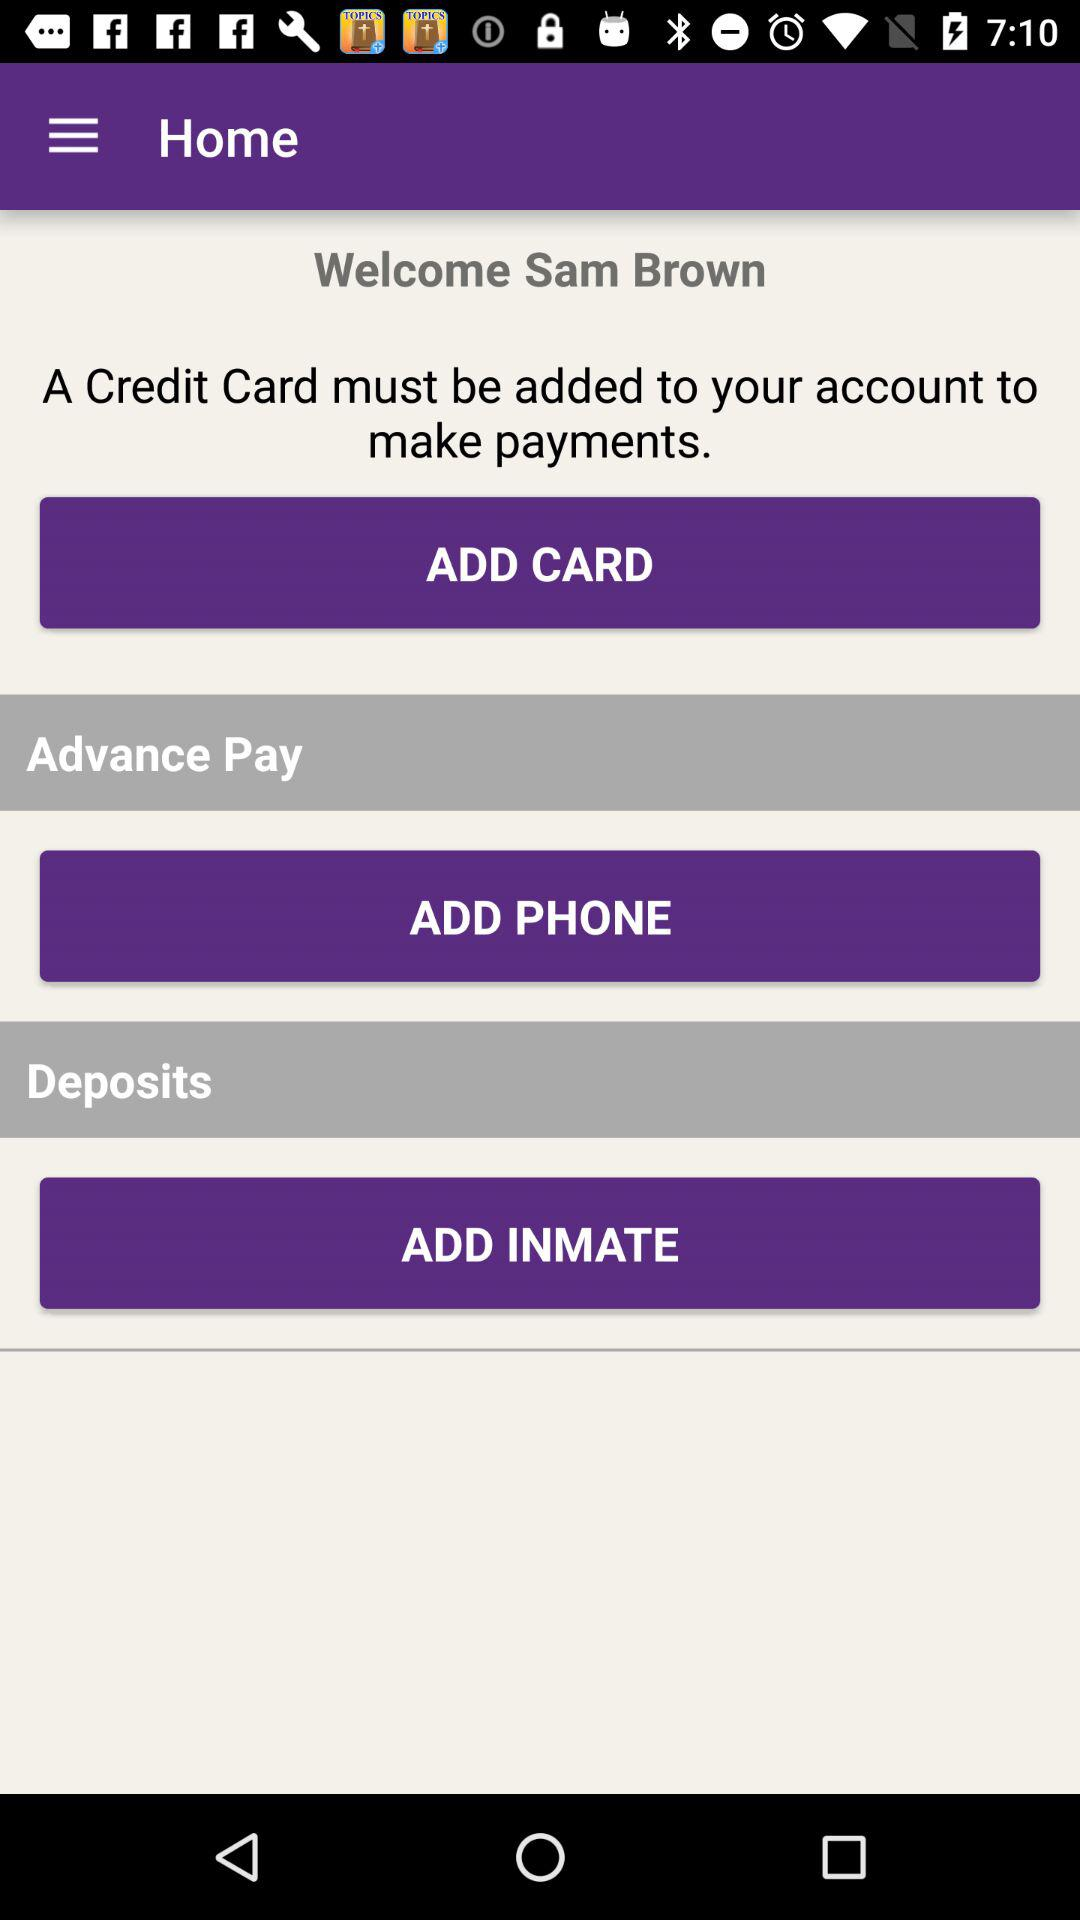What is the user name? The user name is Sam Brown. 